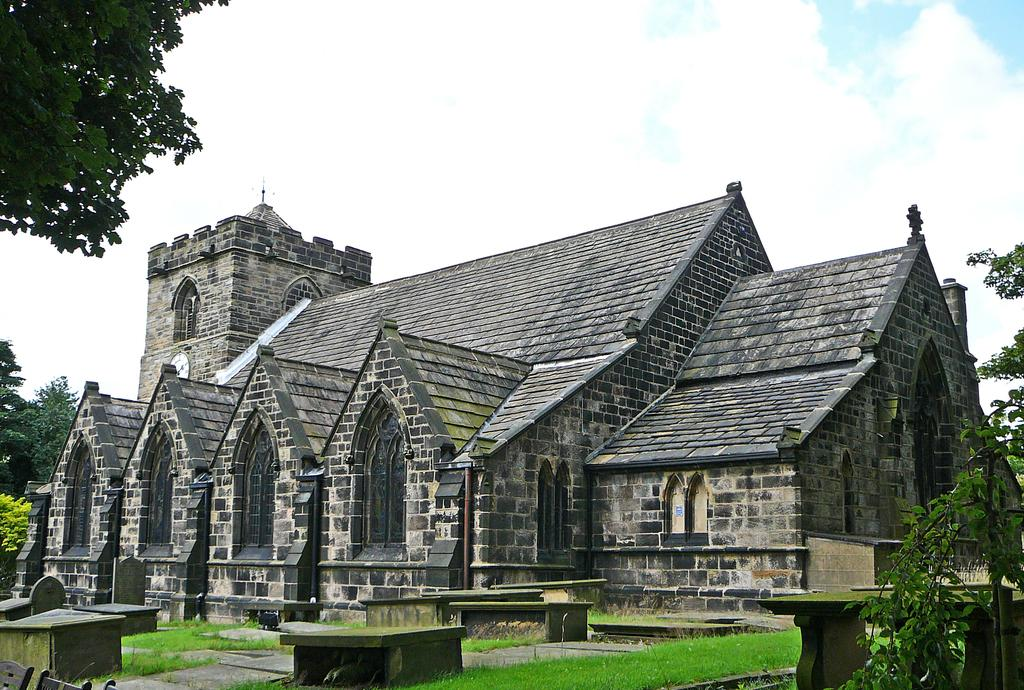What type of structure is visible in the image? There is a building in the image. What colors are used on the building? The building has grey and brown colors. What feature can be seen on the building? The building has windows. What type of seating is present in the image? There are cement benches in the image. What type of vegetation is visible in the image? There are trees in the image. What is the color of the sky in the image? The sky is blue and white in color. Can you see any goldfish swimming in the image? There are no goldfish present in the image. What type of stick is being used by the person in the image? There is no person or stick visible in the image. 